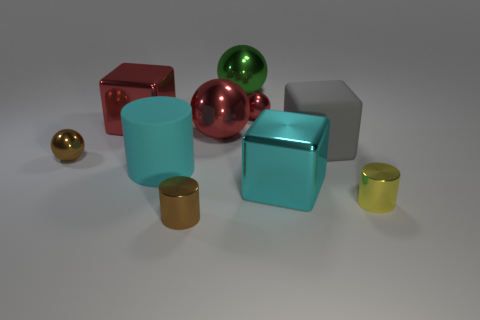What is the color of the cube that is on the right side of the big metallic thing that is on the right side of the large green metallic object?
Ensure brevity in your answer.  Gray. There is a rubber cylinder; is its color the same as the big metal thing in front of the gray rubber object?
Give a very brief answer. Yes. There is a cube that is both behind the cyan shiny block and on the right side of the cyan matte cylinder; what is it made of?
Your answer should be very brief. Rubber. Are there any brown metallic things of the same size as the yellow metallic object?
Ensure brevity in your answer.  Yes. There is a cylinder that is the same size as the green object; what is it made of?
Provide a short and direct response. Rubber. What number of large cyan rubber cylinders are behind the rubber cylinder?
Offer a very short reply. 0. There is a brown metal object behind the small yellow metallic object; does it have the same shape as the green metal object?
Offer a very short reply. Yes. Are there any tiny red things of the same shape as the big green thing?
Your answer should be compact. Yes. There is a large metallic object in front of the big red thing that is right of the large matte cylinder; what shape is it?
Offer a terse response. Cube. How many yellow objects have the same material as the brown ball?
Offer a very short reply. 1. 